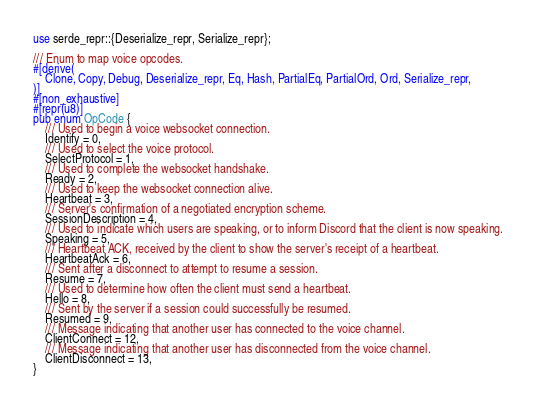Convert code to text. <code><loc_0><loc_0><loc_500><loc_500><_Rust_>use serde_repr::{Deserialize_repr, Serialize_repr};

/// Enum to map voice opcodes.
#[derive(
    Clone, Copy, Debug, Deserialize_repr, Eq, Hash, PartialEq, PartialOrd, Ord, Serialize_repr,
)]
#[non_exhaustive]
#[repr(u8)]
pub enum OpCode {
    /// Used to begin a voice websocket connection.
    Identify = 0,
    /// Used to select the voice protocol.
    SelectProtocol = 1,
    /// Used to complete the websocket handshake.
    Ready = 2,
    /// Used to keep the websocket connection alive.
    Heartbeat = 3,
    /// Server's confirmation of a negotiated encryption scheme.
    SessionDescription = 4,
    /// Used to indicate which users are speaking, or to inform Discord that the client is now speaking.
    Speaking = 5,
    /// Heartbeat ACK, received by the client to show the server's receipt of a heartbeat.
    HeartbeatAck = 6,
    /// Sent after a disconnect to attempt to resume a session.
    Resume = 7,
    /// Used to determine how often the client must send a heartbeat.
    Hello = 8,
    /// Sent by the server if a session could successfully be resumed.
    Resumed = 9,
    /// Message indicating that another user has connected to the voice channel.
    ClientConnect = 12,
    /// Message indicating that another user has disconnected from the voice channel.
    ClientDisconnect = 13,
}
</code> 